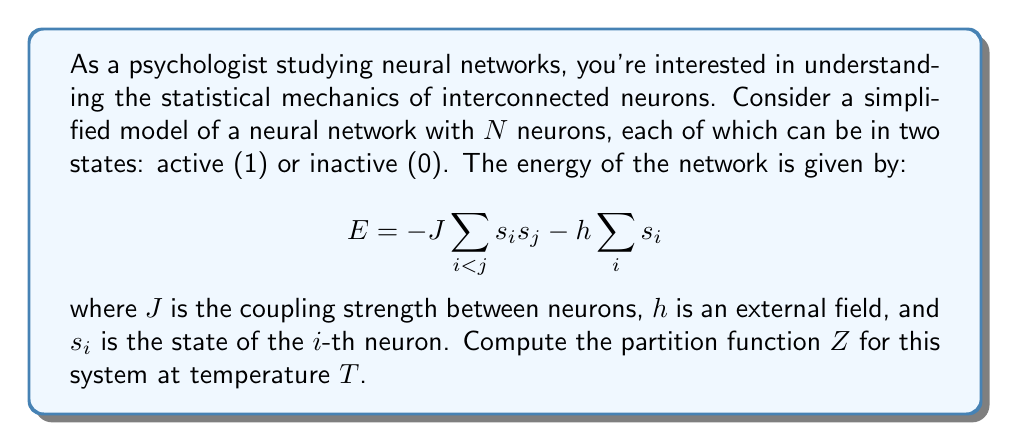Can you solve this math problem? To compute the partition function, we'll follow these steps:

1) The partition function is defined as:
   $$Z = \sum_{\text{all states}} e^{-\beta E}$$
   where $\beta = \frac{1}{k_B T}$, $k_B$ is Boltzmann's constant, and $T$ is temperature.

2) In our case, each neuron can be in two states (0 or 1), so there are $2^N$ possible states for the entire network.

3) Substituting the energy expression into the partition function:
   $$Z = \sum_{\{s_i\}} \exp\left(\beta J \sum_{i<j} s_i s_j + \beta h \sum_i s_i\right)$$

4) This sum is challenging to evaluate directly. However, we can use a trick from statistical mechanics called the Hubbard-Stratonovich transformation. This introduces an auxiliary field $z$ and allows us to decouple the quadratic term:

   $$Z = \int_{-\infty}^{\infty} \frac{dz}{\sqrt{2\pi}} e^{-\frac{z^2}{2}} \sum_{\{s_i\}} \exp\left(z\sqrt{\beta J} \sum_i s_i + \beta h \sum_i s_i\right)$$

5) Now the sum over states factorizes:
   $$Z = \int_{-\infty}^{\infty} \frac{dz}{\sqrt{2\pi}} e^{-\frac{z^2}{2}} \prod_i \sum_{s_i=0,1} \exp\left((z\sqrt{\beta J} + \beta h)s_i\right)$$

6) The sum over $s_i$ can be evaluated:
   $$\sum_{s_i=0,1} \exp\left((z\sqrt{\beta J} + \beta h)s_i\right) = 1 + \exp(z\sqrt{\beta J} + \beta h)$$

7) Therefore, the partition function becomes:
   $$Z = \int_{-\infty}^{\infty} \frac{dz}{\sqrt{2\pi}} e^{-\frac{z^2}{2}} [1 + \exp(z\sqrt{\beta J} + \beta h)]^N$$

This integral form is the final expression for the partition function of this neural network model.
Answer: $$Z = \int_{-\infty}^{\infty} \frac{dz}{\sqrt{2\pi}} e^{-\frac{z^2}{2}} [1 + \exp(z\sqrt{\beta J} + \beta h)]^N$$ 